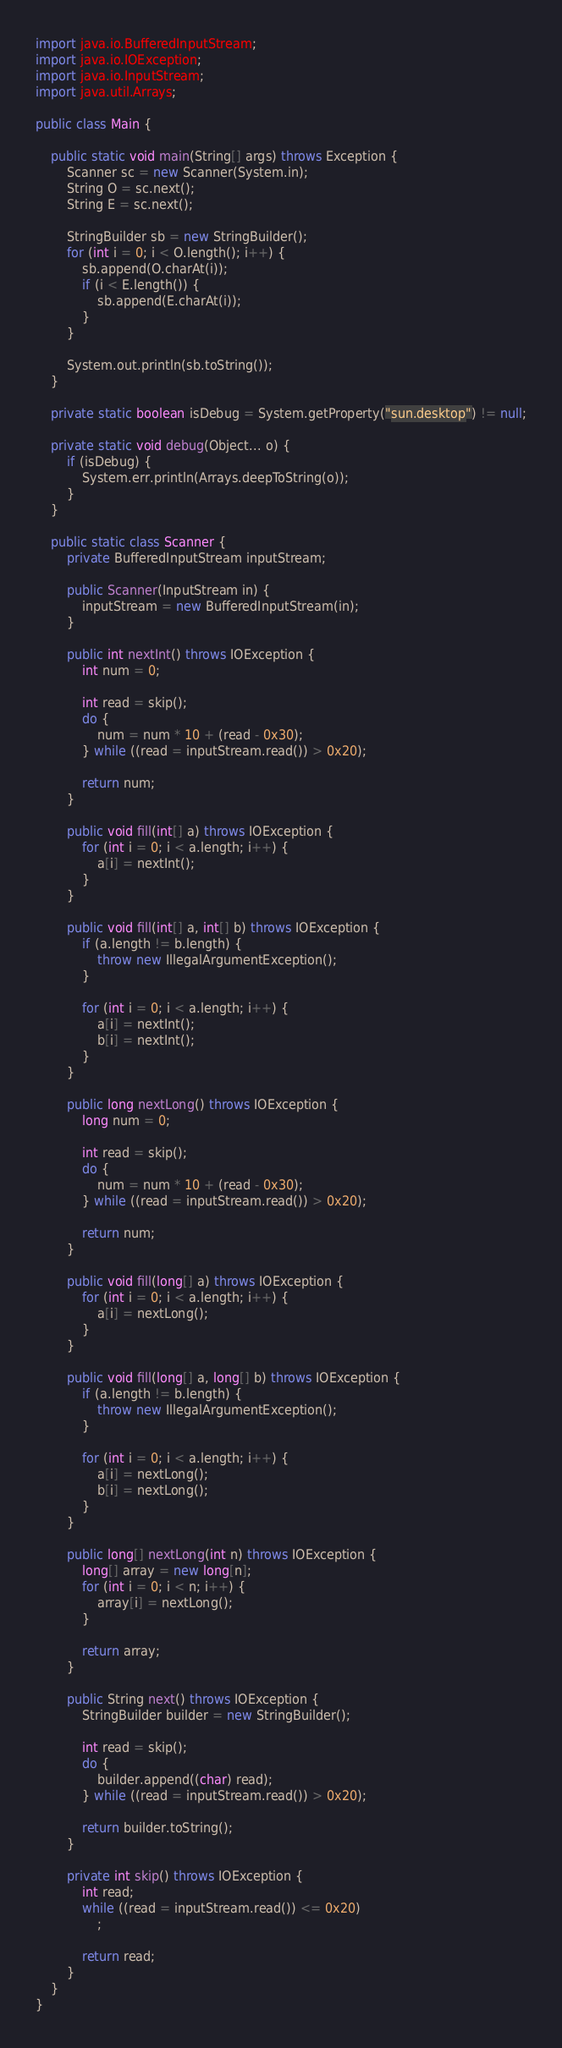<code> <loc_0><loc_0><loc_500><loc_500><_Java_>import java.io.BufferedInputStream;
import java.io.IOException;
import java.io.InputStream;
import java.util.Arrays;

public class Main {

	public static void main(String[] args) throws Exception {
		Scanner sc = new Scanner(System.in);
		String O = sc.next();
		String E = sc.next();

		StringBuilder sb = new StringBuilder();
		for (int i = 0; i < O.length(); i++) {
			sb.append(O.charAt(i));
			if (i < E.length()) {
				sb.append(E.charAt(i));
			}
		}

		System.out.println(sb.toString());
	}

	private static boolean isDebug = System.getProperty("sun.desktop") != null;

	private static void debug(Object... o) {
		if (isDebug) {
			System.err.println(Arrays.deepToString(o));
		}
	}

	public static class Scanner {
		private BufferedInputStream inputStream;

		public Scanner(InputStream in) {
			inputStream = new BufferedInputStream(in);
		}

		public int nextInt() throws IOException {
			int num = 0;

			int read = skip();
			do {
				num = num * 10 + (read - 0x30);
			} while ((read = inputStream.read()) > 0x20);

			return num;
		}

		public void fill(int[] a) throws IOException {
			for (int i = 0; i < a.length; i++) {
				a[i] = nextInt();
			}
		}

		public void fill(int[] a, int[] b) throws IOException {
			if (a.length != b.length) {
				throw new IllegalArgumentException();
			}

			for (int i = 0; i < a.length; i++) {
				a[i] = nextInt();
				b[i] = nextInt();
			}
		}

		public long nextLong() throws IOException {
			long num = 0;

			int read = skip();
			do {
				num = num * 10 + (read - 0x30);
			} while ((read = inputStream.read()) > 0x20);

			return num;
		}

		public void fill(long[] a) throws IOException {
			for (int i = 0; i < a.length; i++) {
				a[i] = nextLong();
			}
		}

		public void fill(long[] a, long[] b) throws IOException {
			if (a.length != b.length) {
				throw new IllegalArgumentException();
			}

			for (int i = 0; i < a.length; i++) {
				a[i] = nextLong();
				b[i] = nextLong();
			}
		}

		public long[] nextLong(int n) throws IOException {
			long[] array = new long[n];
			for (int i = 0; i < n; i++) {
				array[i] = nextLong();
			}

			return array;
		}

		public String next() throws IOException {
			StringBuilder builder = new StringBuilder();

			int read = skip();
			do {
				builder.append((char) read);
			} while ((read = inputStream.read()) > 0x20);

			return builder.toString();
		}

		private int skip() throws IOException {
			int read;
			while ((read = inputStream.read()) <= 0x20)
				;

			return read;
		}
	}
}
</code> 